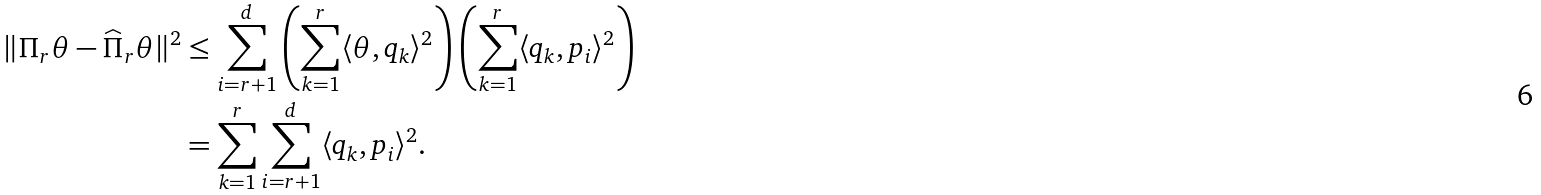<formula> <loc_0><loc_0><loc_500><loc_500>\| \Pi _ { r } \theta - \widehat { \Pi } _ { r } \theta \| ^ { 2 } & \leq \sum _ { i = r + 1 } ^ { d } \left ( \sum _ { k = 1 } ^ { r } \langle \theta , q _ { k } \rangle ^ { 2 } \right ) \left ( \sum _ { k = 1 } ^ { r } \langle q _ { k } , p _ { i } \rangle ^ { 2 } \right ) \\ & = \sum _ { k = 1 } ^ { r } \sum _ { i = r + 1 } ^ { d } \langle q _ { k } , p _ { i } \rangle ^ { 2 } .</formula> 